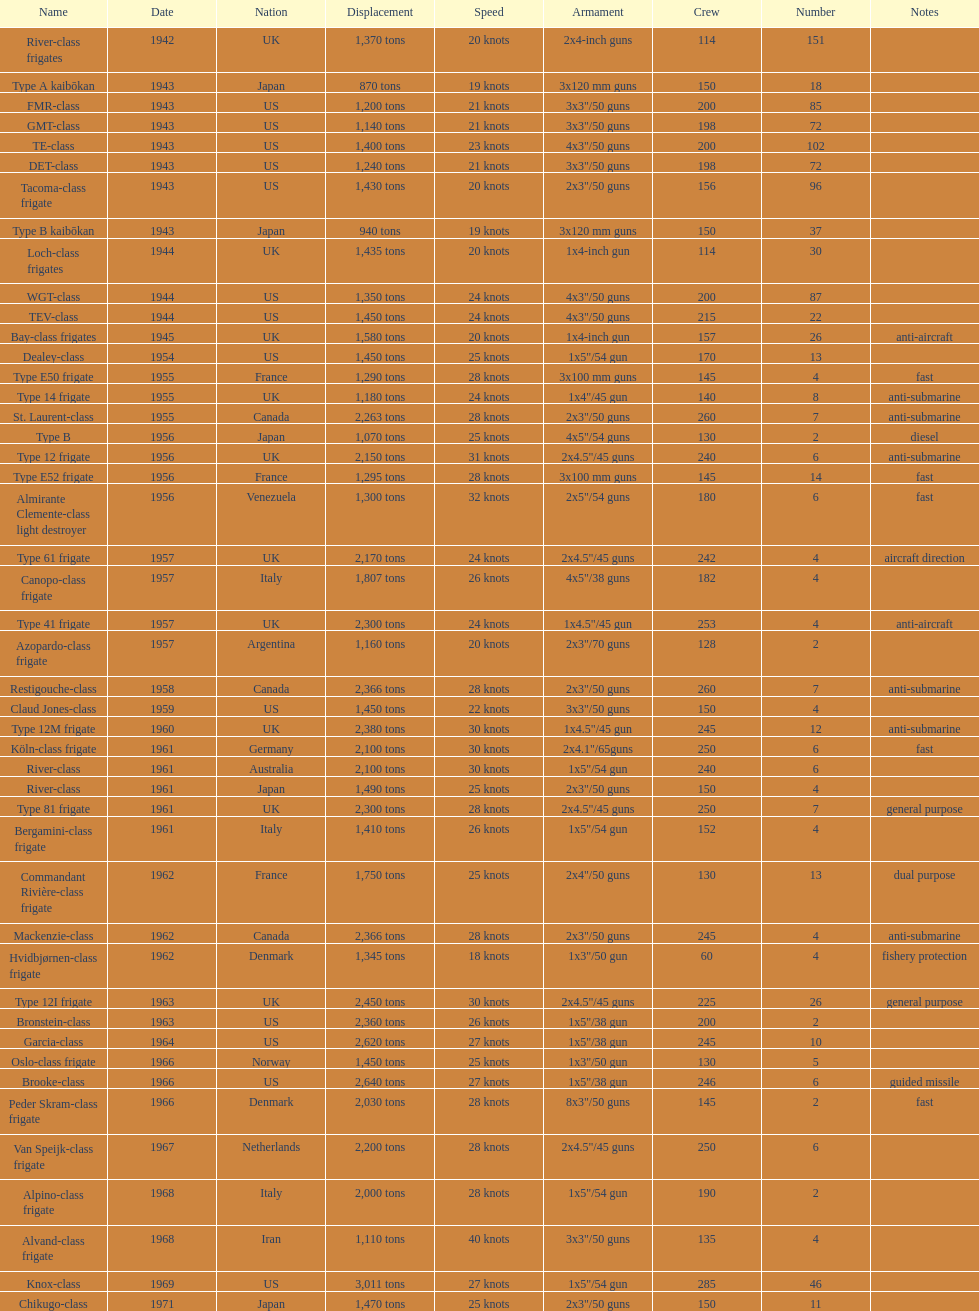How many tons of displacement does type b have? 940 tons. 